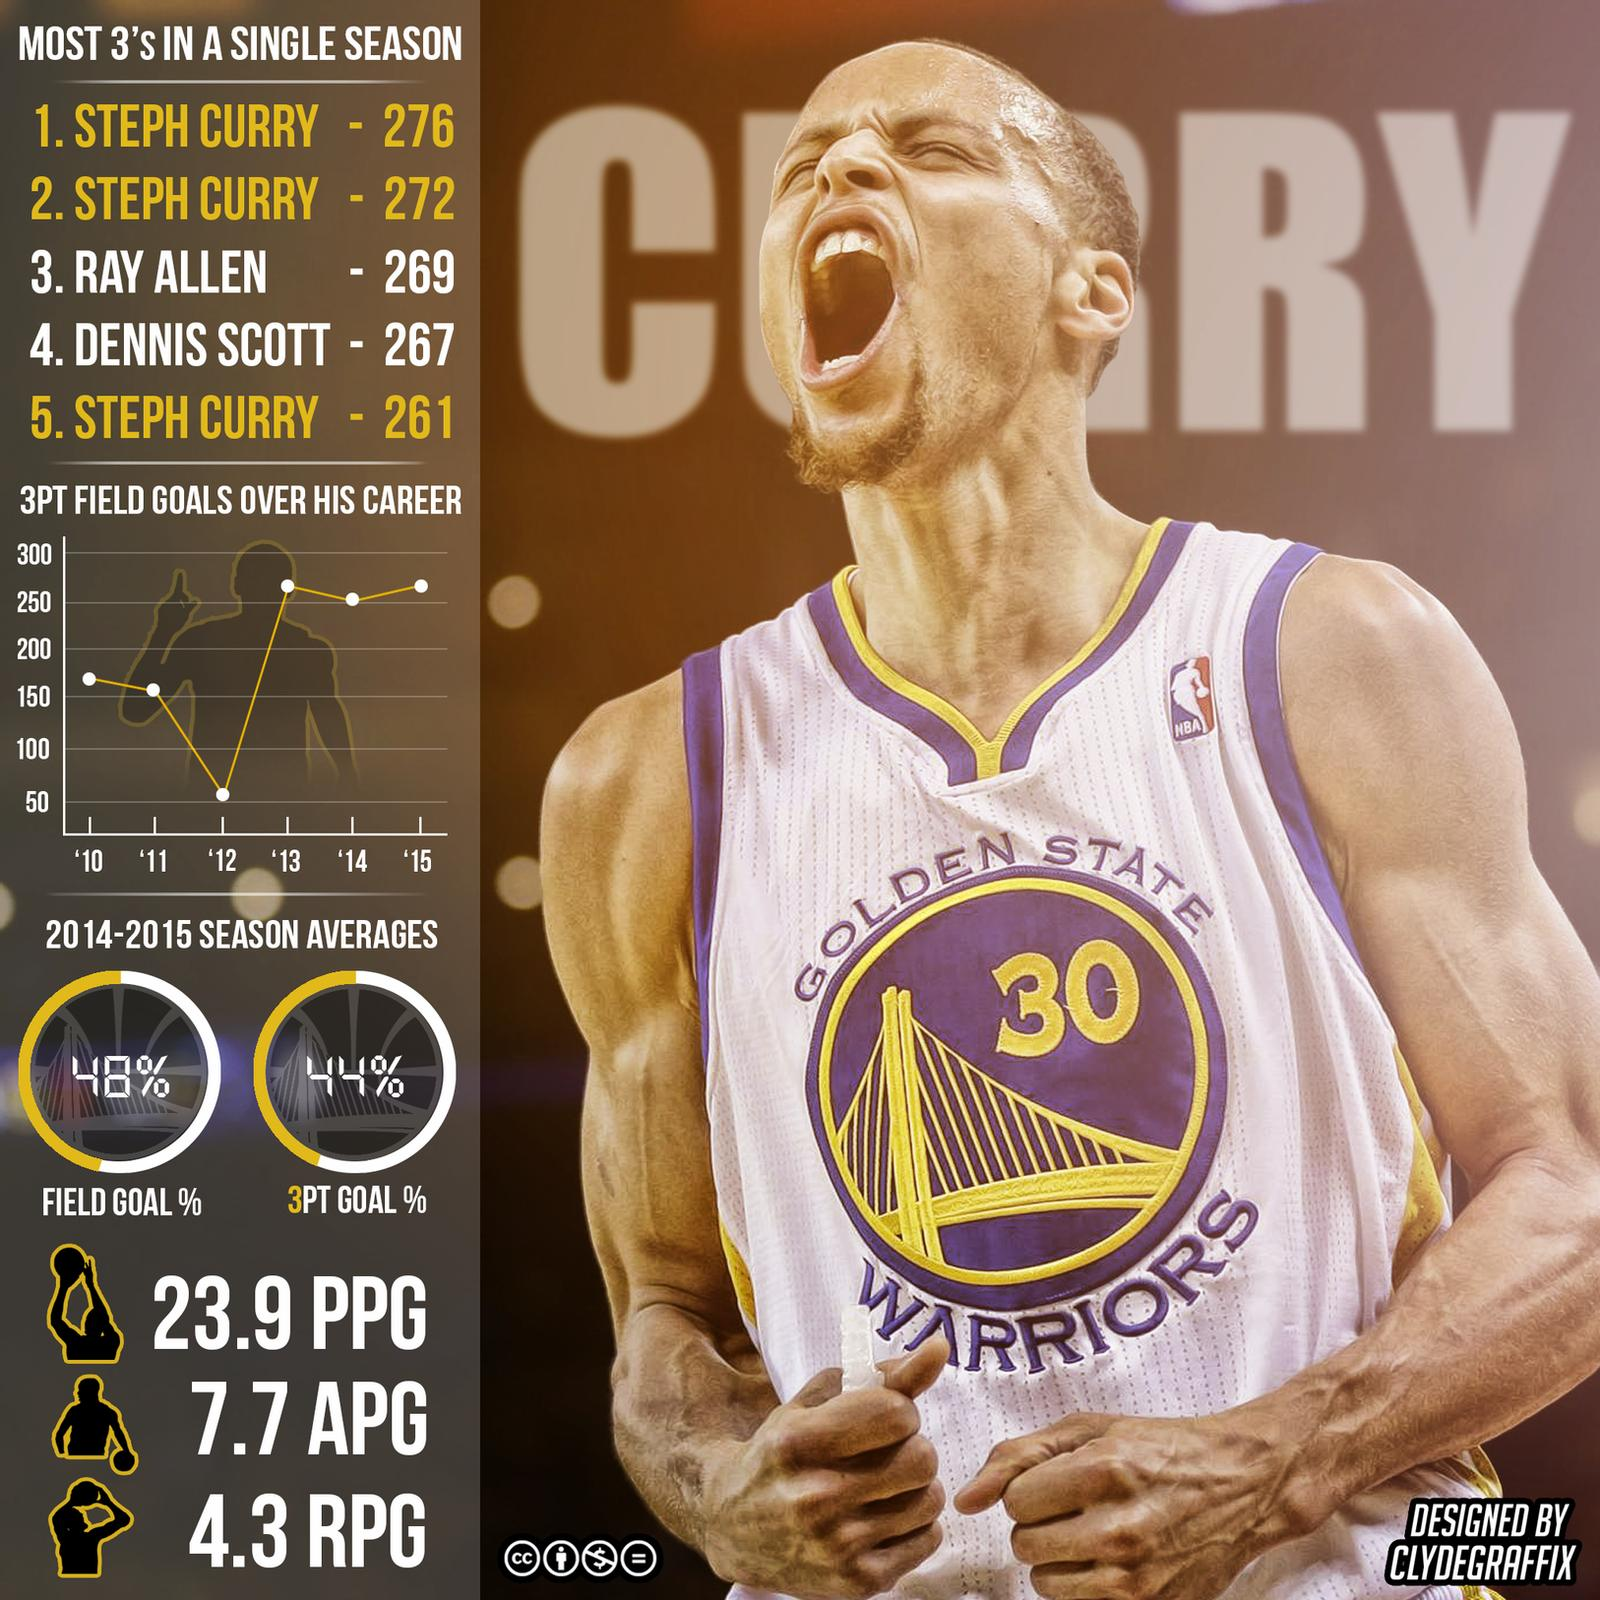Mention a couple of crucial points in this snapshot. Steph Curry is averaging an impressive 23.9 points per game, demonstrating his exceptional scoring ability and contributions to his team's success. Steph Curry provides 7.7 assists per game, demonstrating his exceptional contribution to his team's success. In a three-year period, Steph Curry scored the most three-point shots, demonstrating exceptional shooting ability and consistency. According to statistics, Steph Curry averages 4.3 rebounds per game, demonstrating his impressive all-around game. When did Steph Curry score the least amount of three point field goals? In 2012, he did not score any. 